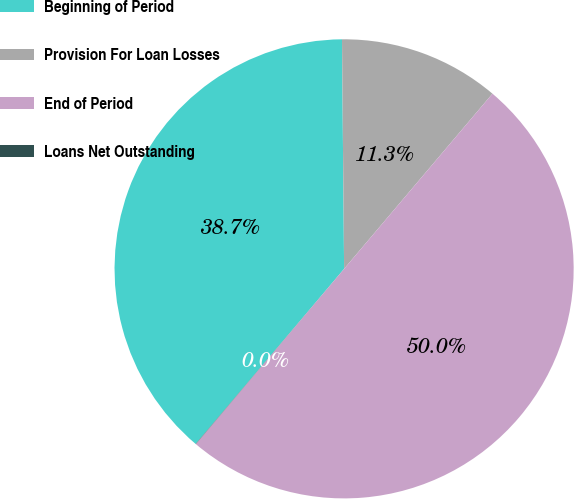<chart> <loc_0><loc_0><loc_500><loc_500><pie_chart><fcel>Beginning of Period<fcel>Provision For Loan Losses<fcel>End of Period<fcel>Loans Net Outstanding<nl><fcel>38.66%<fcel>11.33%<fcel>49.99%<fcel>0.02%<nl></chart> 